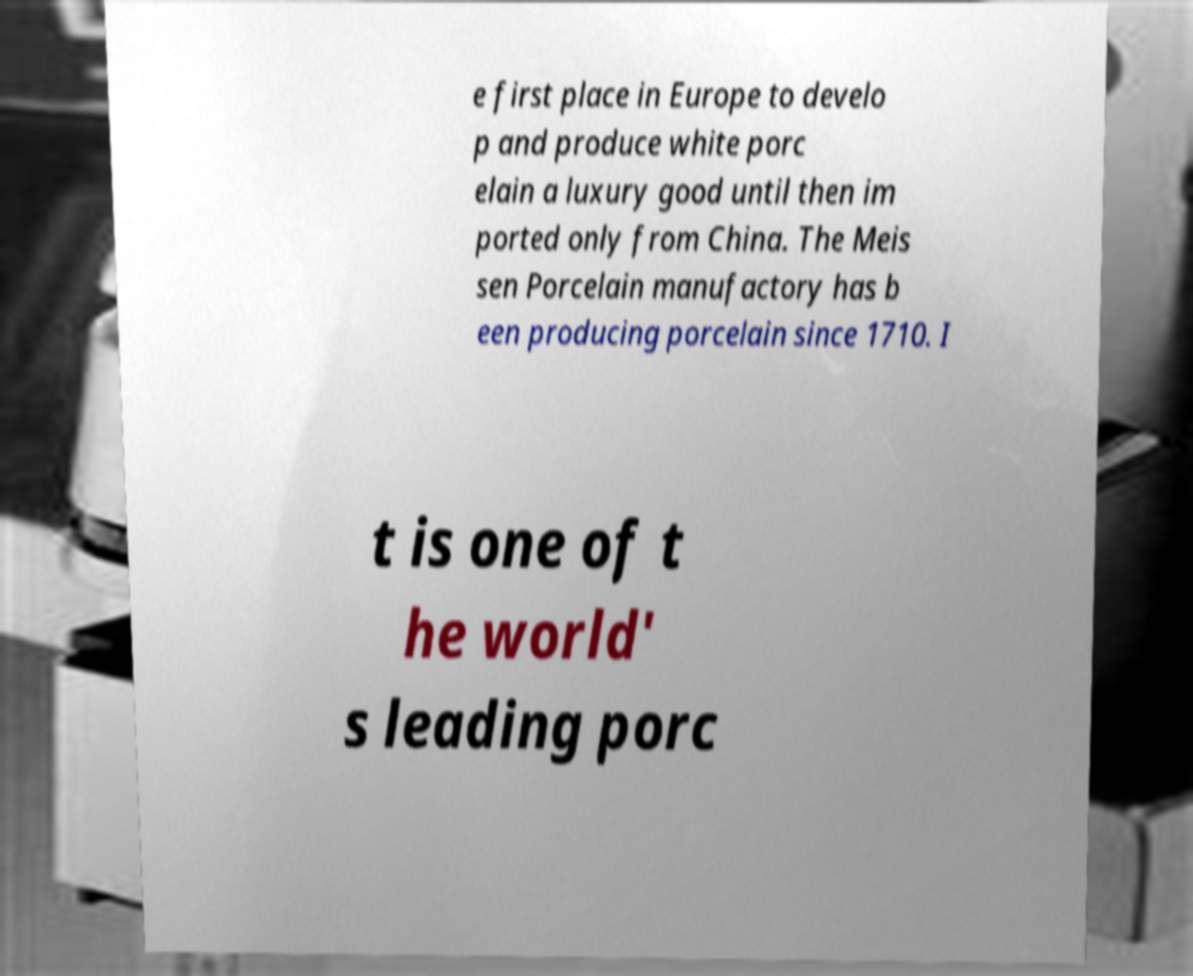There's text embedded in this image that I need extracted. Can you transcribe it verbatim? e first place in Europe to develo p and produce white porc elain a luxury good until then im ported only from China. The Meis sen Porcelain manufactory has b een producing porcelain since 1710. I t is one of t he world' s leading porc 